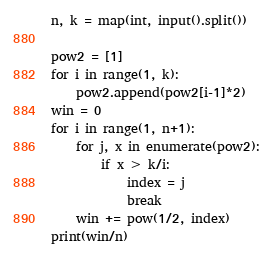<code> <loc_0><loc_0><loc_500><loc_500><_Python_>n, k = map(int, input().split())

pow2 = [1]
for i in range(1, k):
    pow2.append(pow2[i-1]*2)
win = 0
for i in range(1, n+1):
    for j, x in enumerate(pow2):
        if x > k/i:
            index = j
            break
    win += pow(1/2, index)
print(win/n)</code> 